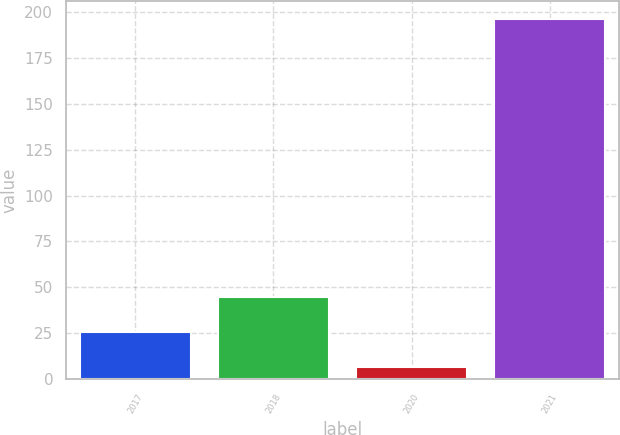<chart> <loc_0><loc_0><loc_500><loc_500><bar_chart><fcel>2017<fcel>2018<fcel>2020<fcel>2021<nl><fcel>25.73<fcel>44.66<fcel>6.8<fcel>196.1<nl></chart> 